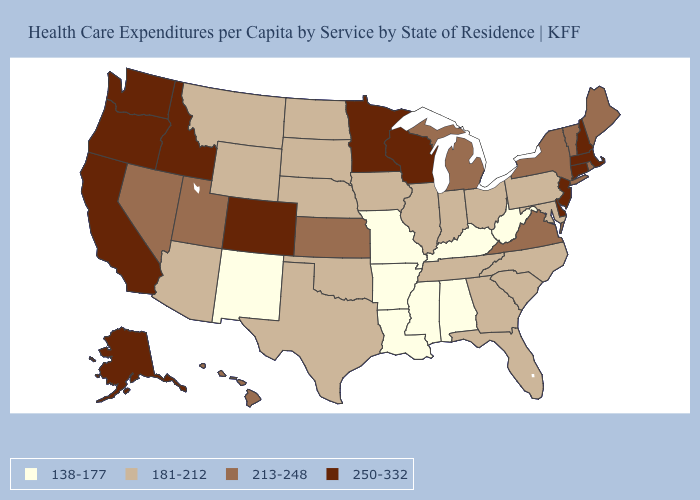Which states hav the highest value in the Northeast?
Answer briefly. Connecticut, Massachusetts, New Hampshire, New Jersey. Among the states that border Vermont , which have the lowest value?
Keep it brief. New York. Name the states that have a value in the range 181-212?
Short answer required. Arizona, Florida, Georgia, Illinois, Indiana, Iowa, Maryland, Montana, Nebraska, North Carolina, North Dakota, Ohio, Oklahoma, Pennsylvania, South Carolina, South Dakota, Tennessee, Texas, Wyoming. Which states hav the highest value in the MidWest?
Short answer required. Minnesota, Wisconsin. Does Delaware have the highest value in the South?
Concise answer only. Yes. Among the states that border New York , does New Jersey have the lowest value?
Concise answer only. No. What is the lowest value in states that border Nevada?
Be succinct. 181-212. Name the states that have a value in the range 213-248?
Quick response, please. Hawaii, Kansas, Maine, Michigan, Nevada, New York, Rhode Island, Utah, Vermont, Virginia. Does Missouri have the lowest value in the MidWest?
Give a very brief answer. Yes. Does South Carolina have a lower value than Washington?
Concise answer only. Yes. What is the highest value in the South ?
Short answer required. 250-332. Name the states that have a value in the range 138-177?
Concise answer only. Alabama, Arkansas, Kentucky, Louisiana, Mississippi, Missouri, New Mexico, West Virginia. Name the states that have a value in the range 250-332?
Answer briefly. Alaska, California, Colorado, Connecticut, Delaware, Idaho, Massachusetts, Minnesota, New Hampshire, New Jersey, Oregon, Washington, Wisconsin. What is the value of Utah?
Be succinct. 213-248. 